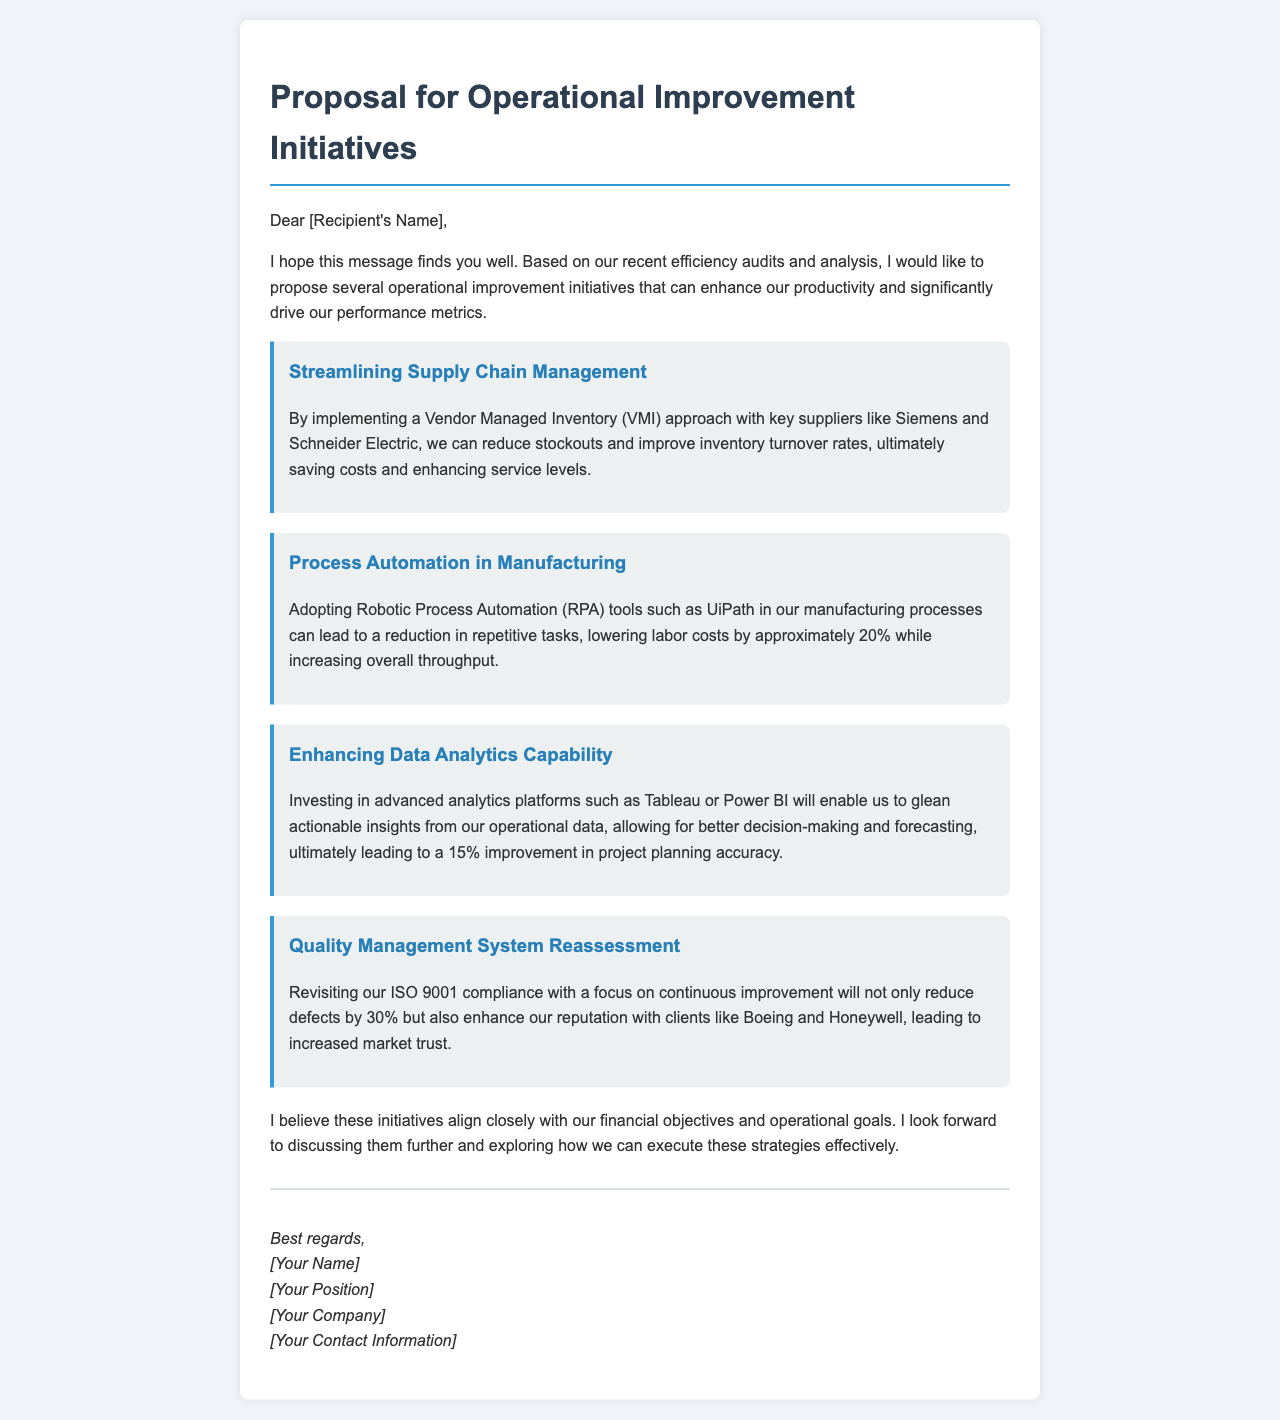What is the first initiative proposed? The first initiative mentioned in the document is focused on streamlining supply chain management.
Answer: Streamlining Supply Chain Management What percentage can labor costs be reduced by adopting RPA tools? The document states that labor costs can be lowered by approximately 20% through the adoption of RPA tools.
Answer: 20% Which suppliers are mentioned for the Vendor Managed Inventory approach? Siemens and Schneider Electric are the key suppliers mentioned for the Vendor Managed Inventory approach.
Answer: Siemens and Schneider Electric What improvement in project planning accuracy is expected from investing in advanced analytics platforms? The document mentions a 15% improvement in project planning accuracy as a result of investing in advanced analytics platforms.
Answer: 15% What ISO standard is referenced for the quality management system reassessment? The document references ISO 9001 for the quality management system reassessment.
Answer: ISO 9001 How much can defects be reduced by focusing on continuous improvement? The document states that defects can be reduced by 30% through a focus on continuous improvement.
Answer: 30% What is the overall goal of the proposed operational improvement initiatives? The overall goal is to enhance productivity and significantly drive performance metrics as stated in the document.
Answer: Enhance productivity and drive performance metrics What platforms are suggested for enhancing data analytics capability? The document suggests investing in Tableau or Power BI for enhancing data analytics capability.
Answer: Tableau or Power BI Who is the intended audience of the email proposal? The proposal is addressed to [Recipient's Name], indicating the intended audience is likely an internal stakeholder or decision-maker.
Answer: [Recipient's Name] 